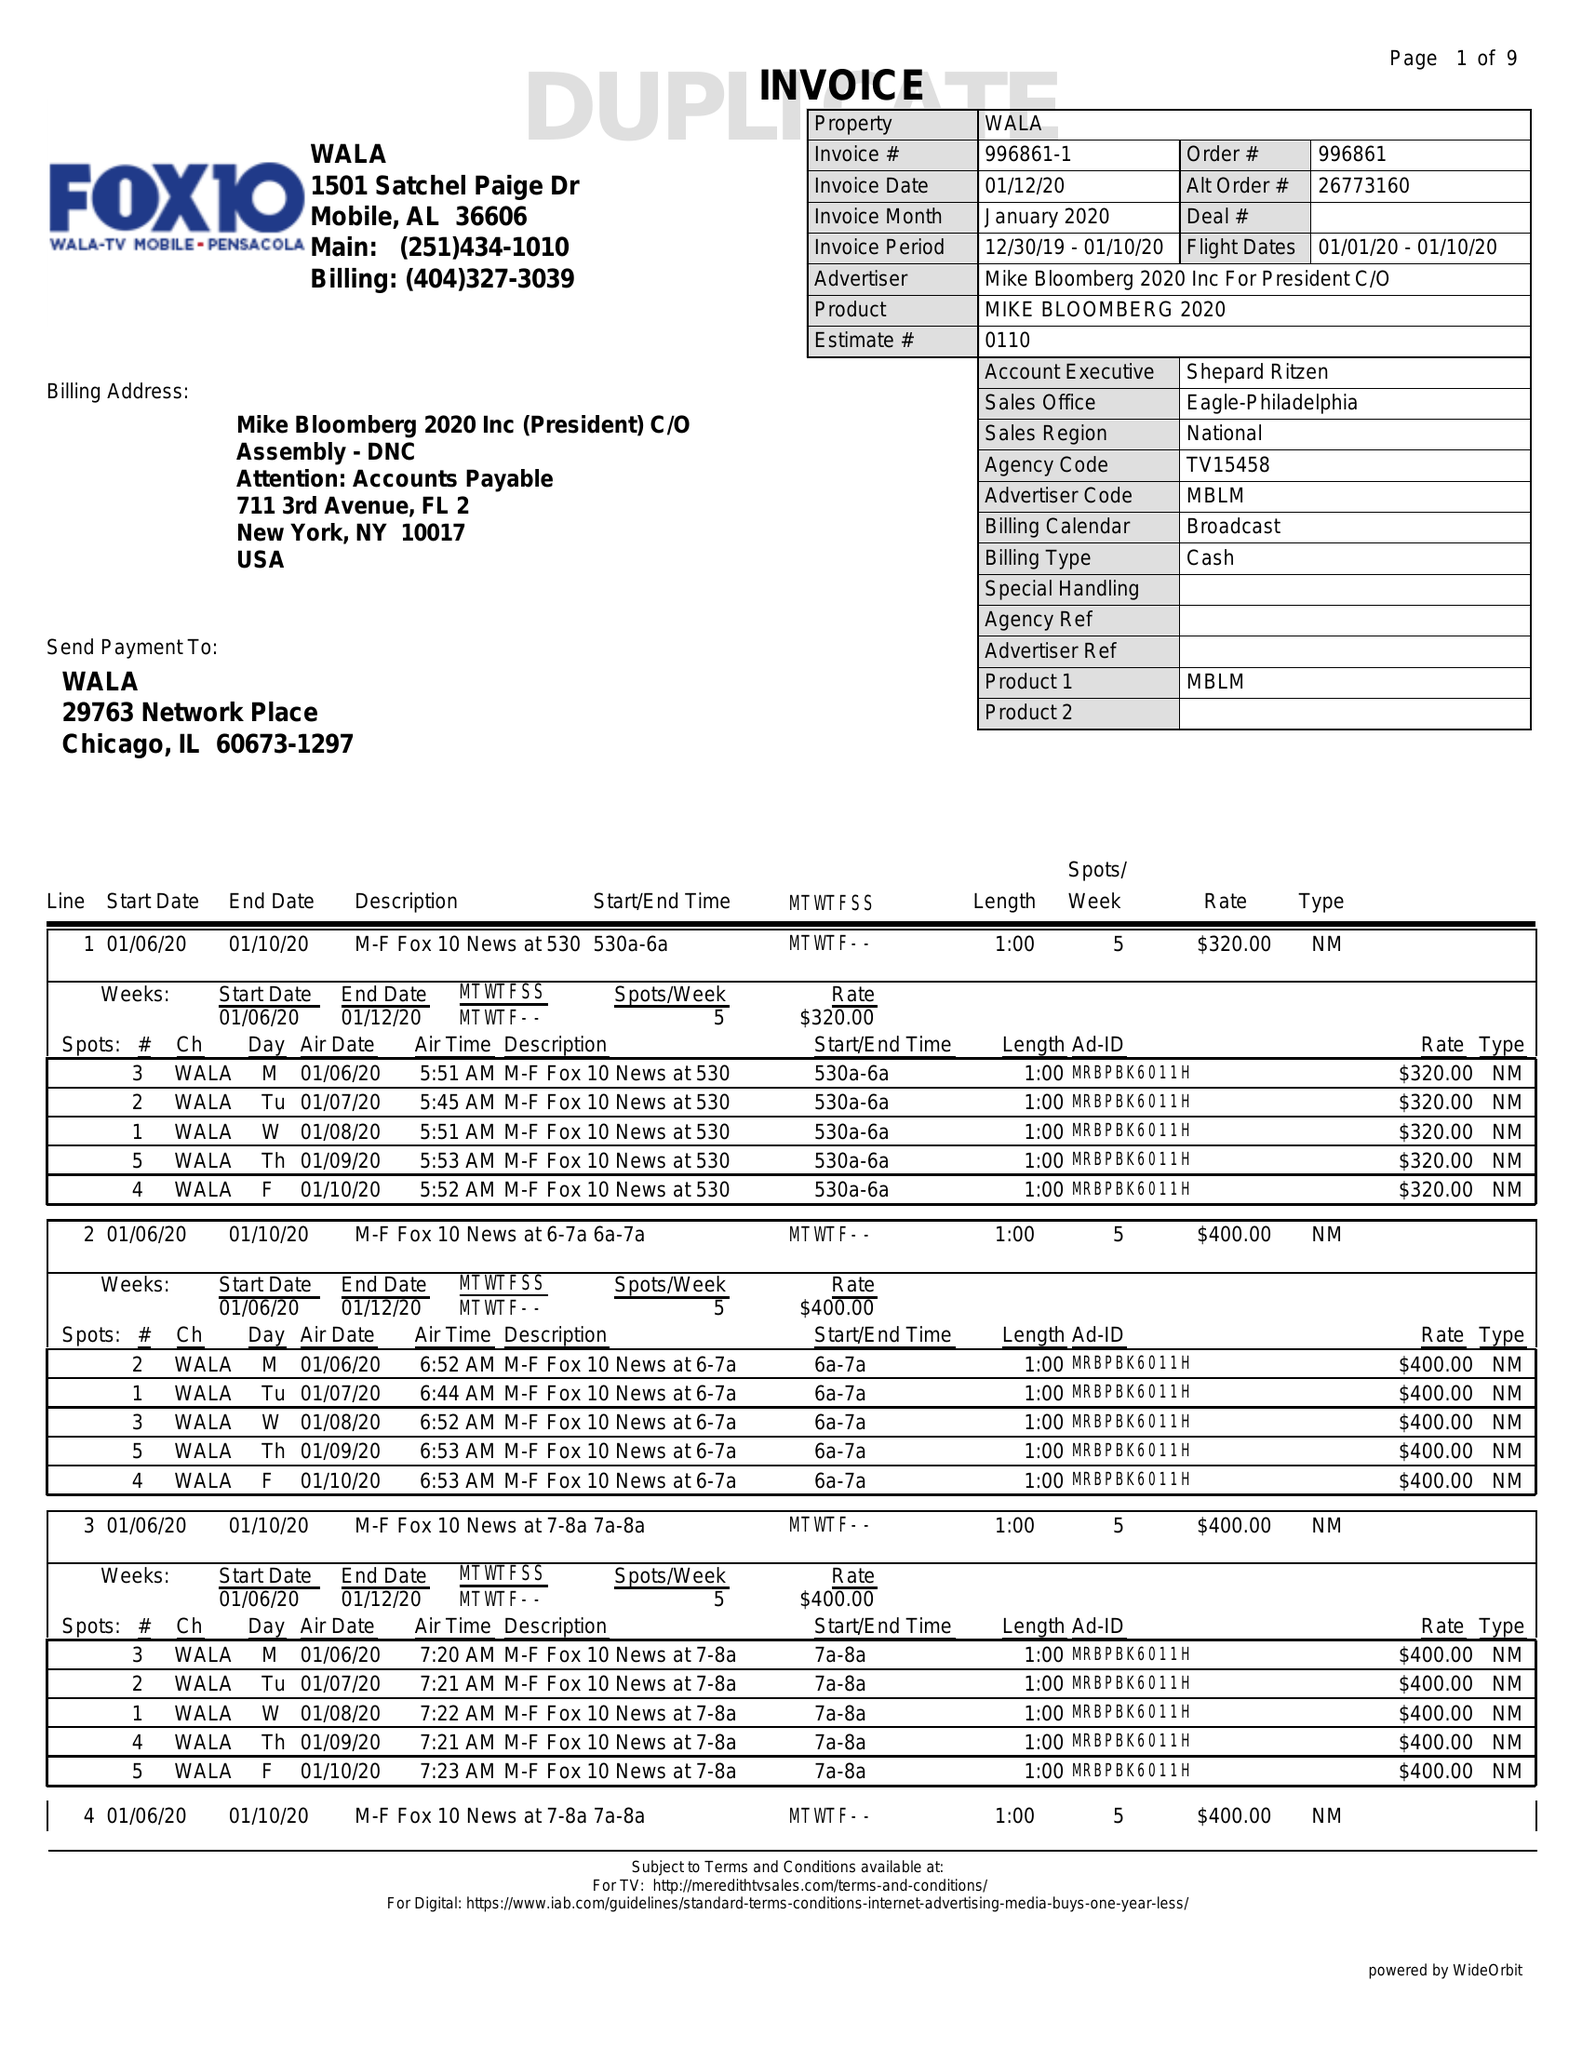What is the value for the gross_amount?
Answer the question using a single word or phrase. 91800.00 